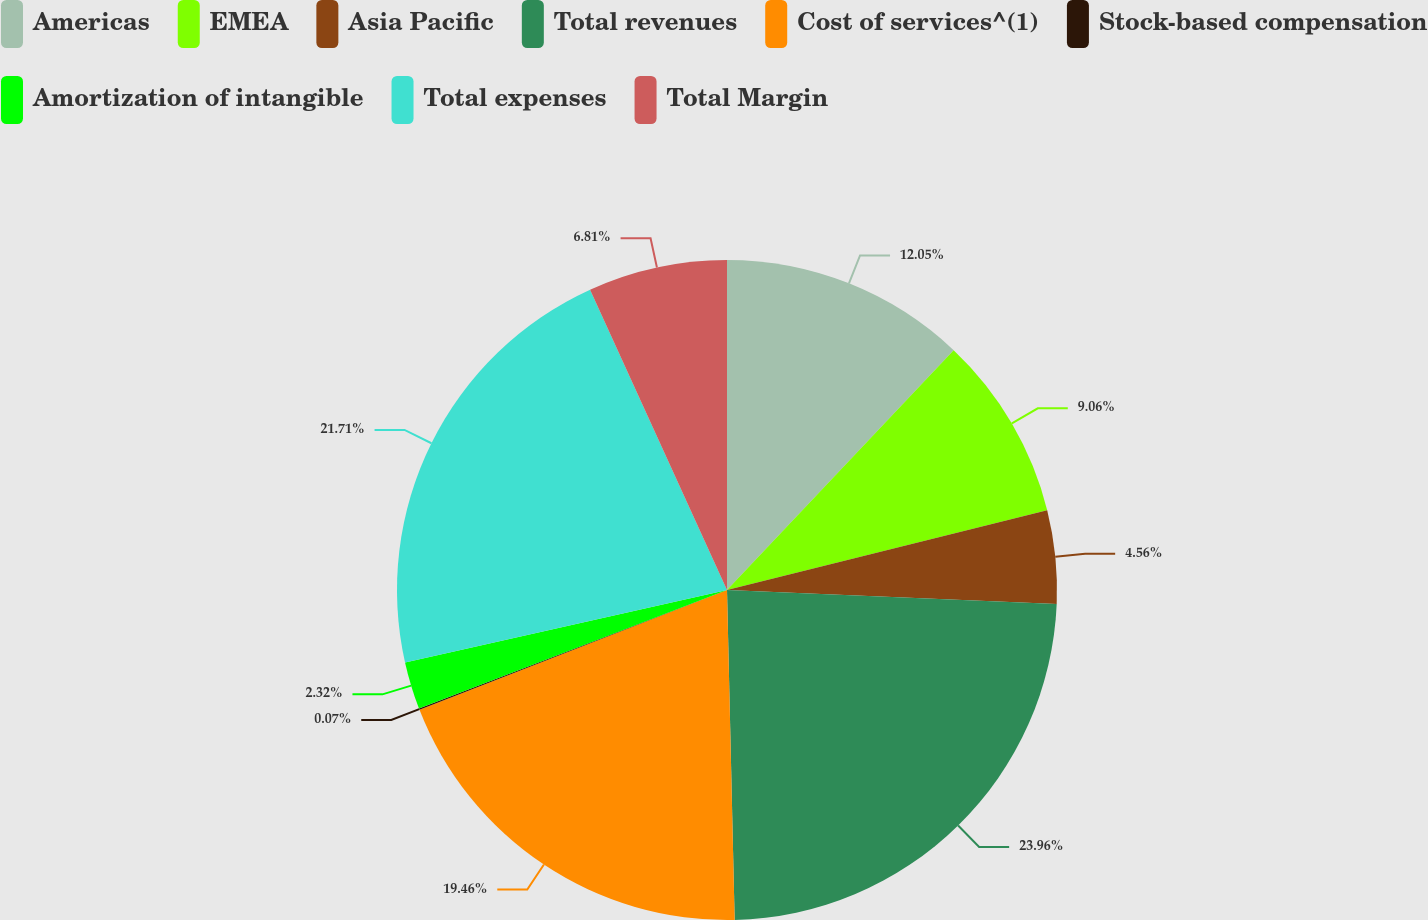<chart> <loc_0><loc_0><loc_500><loc_500><pie_chart><fcel>Americas<fcel>EMEA<fcel>Asia Pacific<fcel>Total revenues<fcel>Cost of services^(1)<fcel>Stock-based compensation<fcel>Amortization of intangible<fcel>Total expenses<fcel>Total Margin<nl><fcel>12.05%<fcel>9.06%<fcel>4.56%<fcel>23.96%<fcel>19.46%<fcel>0.07%<fcel>2.32%<fcel>21.71%<fcel>6.81%<nl></chart> 